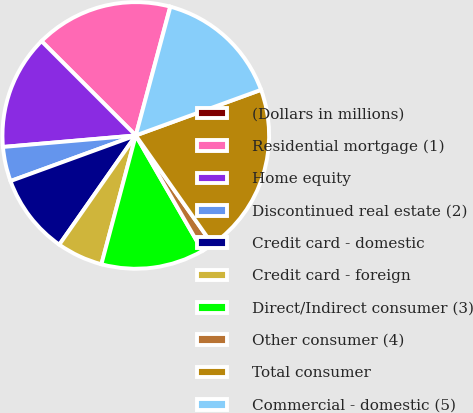Convert chart to OTSL. <chart><loc_0><loc_0><loc_500><loc_500><pie_chart><fcel>(Dollars in millions)<fcel>Residential mortgage (1)<fcel>Home equity<fcel>Discontinued real estate (2)<fcel>Credit card - domestic<fcel>Credit card - foreign<fcel>Direct/Indirect consumer (3)<fcel>Other consumer (4)<fcel>Total consumer<fcel>Commercial - domestic (5)<nl><fcel>0.03%<fcel>16.65%<fcel>13.88%<fcel>4.18%<fcel>9.72%<fcel>5.57%<fcel>12.49%<fcel>1.42%<fcel>20.8%<fcel>15.26%<nl></chart> 